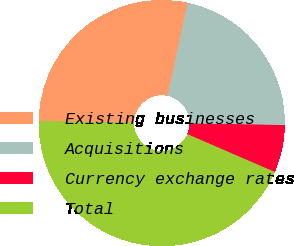<chart> <loc_0><loc_0><loc_500><loc_500><pie_chart><fcel>Existing businesses<fcel>Acquisitions<fcel>Currency exchange rates<fcel>Total<nl><fcel>28.12%<fcel>21.88%<fcel>6.25%<fcel>43.75%<nl></chart> 